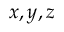Convert formula to latex. <formula><loc_0><loc_0><loc_500><loc_500>x , y , z</formula> 